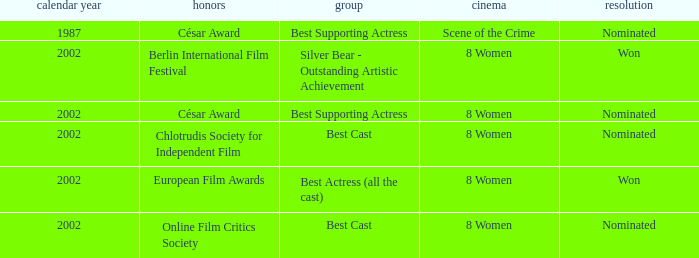What was the result at the Berlin International Film Festival in a year greater than 1987? Won. 